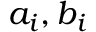<formula> <loc_0><loc_0><loc_500><loc_500>a _ { i } , b _ { i }</formula> 